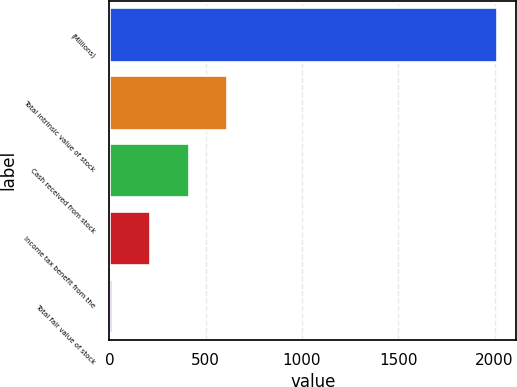Convert chart to OTSL. <chart><loc_0><loc_0><loc_500><loc_500><bar_chart><fcel>(Millions)<fcel>Total intrinsic value of stock<fcel>Cash received from stock<fcel>Income tax benefit from the<fcel>Total fair value of stock<nl><fcel>2013<fcel>611.6<fcel>411.4<fcel>211.2<fcel>11<nl></chart> 